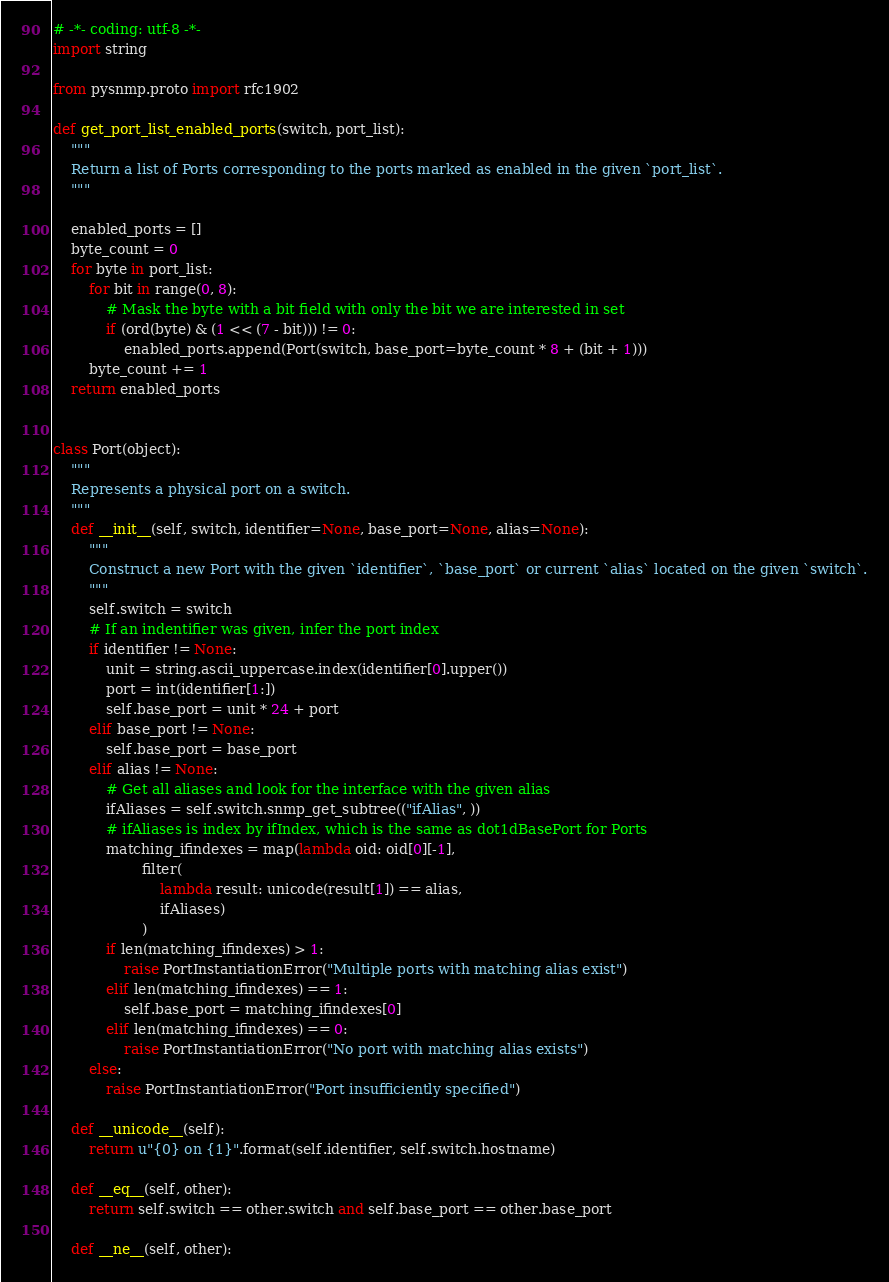Convert code to text. <code><loc_0><loc_0><loc_500><loc_500><_Python_># -*- coding: utf-8 -*-
import string

from pysnmp.proto import rfc1902

def get_port_list_enabled_ports(switch, port_list):
    """
    Return a list of Ports corresponding to the ports marked as enabled in the given `port_list`.
    """

    enabled_ports = []
    byte_count = 0
    for byte in port_list:
        for bit in range(0, 8):
            # Mask the byte with a bit field with only the bit we are interested in set
            if (ord(byte) & (1 << (7 - bit))) != 0:
                enabled_ports.append(Port(switch, base_port=byte_count * 8 + (bit + 1)))
        byte_count += 1
    return enabled_ports


class Port(object):
    """
    Represents a physical port on a switch.
    """
    def __init__(self, switch, identifier=None, base_port=None, alias=None):
        """
        Construct a new Port with the given `identifier`, `base_port` or current `alias` located on the given `switch`.
        """
        self.switch = switch
        # If an indentifier was given, infer the port index
        if identifier != None:
            unit = string.ascii_uppercase.index(identifier[0].upper())
            port = int(identifier[1:])
            self.base_port = unit * 24 + port
        elif base_port != None:
            self.base_port = base_port
        elif alias != None:
            # Get all aliases and look for the interface with the given alias
            ifAliases = self.switch.snmp_get_subtree(("ifAlias", ))
            # ifAliases is index by ifIndex, which is the same as dot1dBasePort for Ports
            matching_ifindexes = map(lambda oid: oid[0][-1],
                    filter(
                        lambda result: unicode(result[1]) == alias,
                        ifAliases)
                    )
            if len(matching_ifindexes) > 1:
                raise PortInstantiationError("Multiple ports with matching alias exist")
            elif len(matching_ifindexes) == 1:
                self.base_port = matching_ifindexes[0]
            elif len(matching_ifindexes) == 0:
                raise PortInstantiationError("No port with matching alias exists")
        else:
            raise PortInstantiationError("Port insufficiently specified")

    def __unicode__(self):
        return u"{0} on {1}".format(self.identifier, self.switch.hostname)

    def __eq__(self, other):
        return self.switch == other.switch and self.base_port == other.base_port

    def __ne__(self, other):</code> 